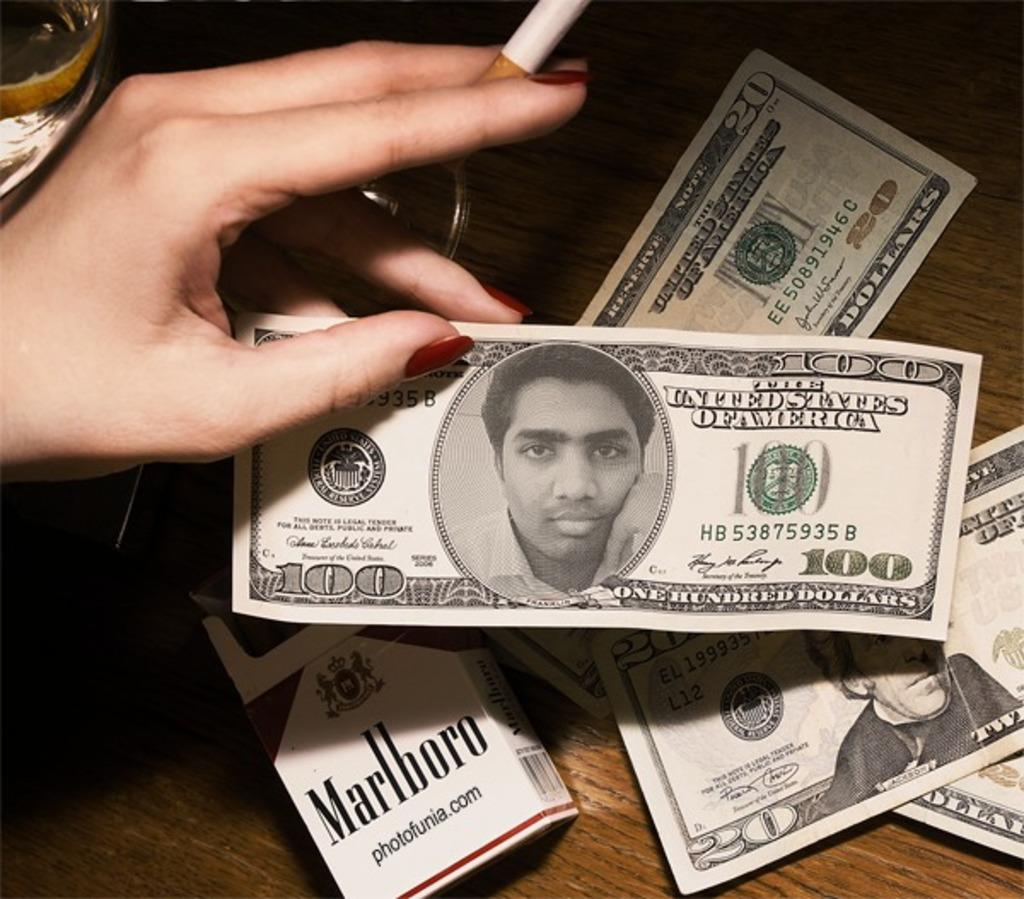What type of currency is visible in the image? There are dollar notes in the image. What other object can be seen on the table in the image? There is a cigarette pack on a table in the image. What is the lady in the image holding? The lady is holding a cigarette and a note in the image. Where are all the elements mentioned located? The elements mentioned are on a table in the image. How many frogs are jumping on the table in the image? There are no frogs present in the image. What type of game is being played on the table in the image? There is no game being played on the table in the image. 